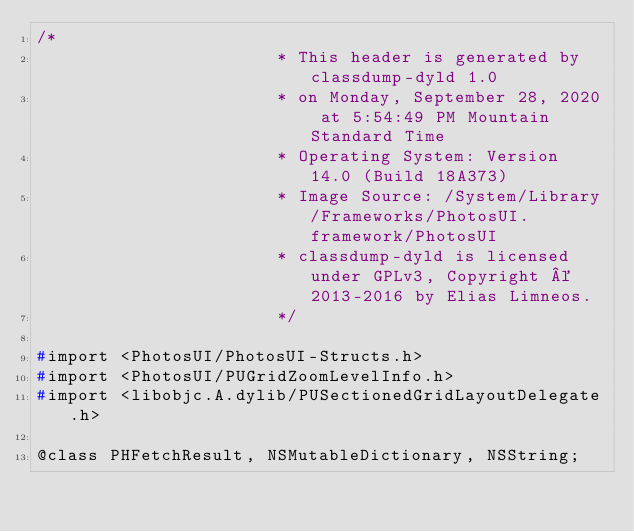Convert code to text. <code><loc_0><loc_0><loc_500><loc_500><_C_>/*
                       * This header is generated by classdump-dyld 1.0
                       * on Monday, September 28, 2020 at 5:54:49 PM Mountain Standard Time
                       * Operating System: Version 14.0 (Build 18A373)
                       * Image Source: /System/Library/Frameworks/PhotosUI.framework/PhotosUI
                       * classdump-dyld is licensed under GPLv3, Copyright © 2013-2016 by Elias Limneos.
                       */

#import <PhotosUI/PhotosUI-Structs.h>
#import <PhotosUI/PUGridZoomLevelInfo.h>
#import <libobjc.A.dylib/PUSectionedGridLayoutDelegate.h>

@class PHFetchResult, NSMutableDictionary, NSString;
</code> 